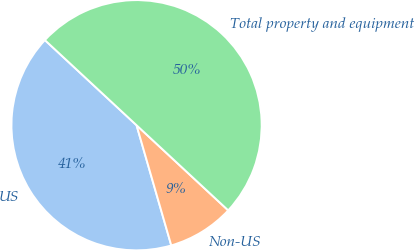Convert chart. <chart><loc_0><loc_0><loc_500><loc_500><pie_chart><fcel>US<fcel>Non-US<fcel>Total property and equipment<nl><fcel>41.39%<fcel>8.61%<fcel>50.0%<nl></chart> 